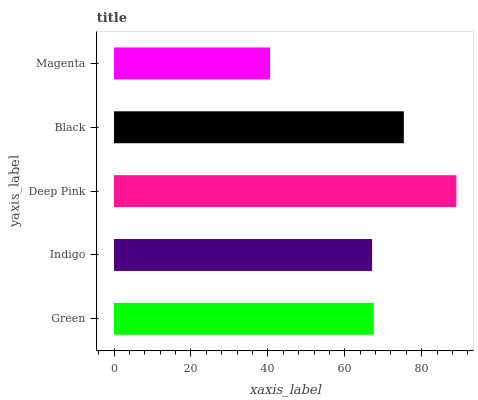Is Magenta the minimum?
Answer yes or no. Yes. Is Deep Pink the maximum?
Answer yes or no. Yes. Is Indigo the minimum?
Answer yes or no. No. Is Indigo the maximum?
Answer yes or no. No. Is Green greater than Indigo?
Answer yes or no. Yes. Is Indigo less than Green?
Answer yes or no. Yes. Is Indigo greater than Green?
Answer yes or no. No. Is Green less than Indigo?
Answer yes or no. No. Is Green the high median?
Answer yes or no. Yes. Is Green the low median?
Answer yes or no. Yes. Is Black the high median?
Answer yes or no. No. Is Magenta the low median?
Answer yes or no. No. 